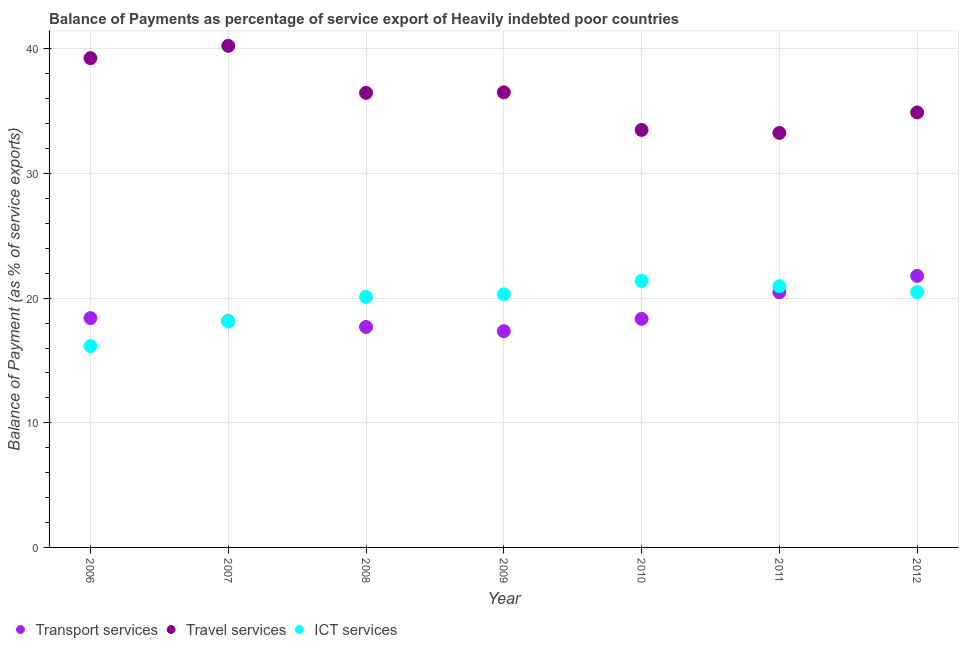Is the number of dotlines equal to the number of legend labels?
Make the answer very short. Yes. What is the balance of payment of ict services in 2012?
Your answer should be compact. 20.48. Across all years, what is the maximum balance of payment of transport services?
Give a very brief answer. 21.79. Across all years, what is the minimum balance of payment of transport services?
Make the answer very short. 17.36. What is the total balance of payment of transport services in the graph?
Your answer should be compact. 132.2. What is the difference between the balance of payment of transport services in 2007 and that in 2010?
Offer a terse response. -0.18. What is the difference between the balance of payment of travel services in 2010 and the balance of payment of transport services in 2012?
Provide a succinct answer. 11.71. What is the average balance of payment of travel services per year?
Provide a succinct answer. 36.31. In the year 2009, what is the difference between the balance of payment of transport services and balance of payment of travel services?
Your answer should be compact. -19.16. In how many years, is the balance of payment of travel services greater than 38 %?
Your answer should be compact. 2. What is the ratio of the balance of payment of transport services in 2008 to that in 2009?
Your response must be concise. 1.02. Is the balance of payment of transport services in 2011 less than that in 2012?
Your answer should be very brief. Yes. Is the difference between the balance of payment of ict services in 2009 and 2012 greater than the difference between the balance of payment of travel services in 2009 and 2012?
Your response must be concise. No. What is the difference between the highest and the second highest balance of payment of ict services?
Make the answer very short. 0.43. What is the difference between the highest and the lowest balance of payment of ict services?
Your response must be concise. 5.23. Is the balance of payment of ict services strictly less than the balance of payment of travel services over the years?
Offer a terse response. Yes. How many years are there in the graph?
Offer a terse response. 7. Does the graph contain any zero values?
Keep it short and to the point. No. Does the graph contain grids?
Keep it short and to the point. Yes. Where does the legend appear in the graph?
Ensure brevity in your answer.  Bottom left. What is the title of the graph?
Your response must be concise. Balance of Payments as percentage of service export of Heavily indebted poor countries. What is the label or title of the X-axis?
Offer a terse response. Year. What is the label or title of the Y-axis?
Provide a short and direct response. Balance of Payment (as % of service exports). What is the Balance of Payment (as % of service exports) in Transport services in 2006?
Make the answer very short. 18.4. What is the Balance of Payment (as % of service exports) of Travel services in 2006?
Provide a short and direct response. 39.26. What is the Balance of Payment (as % of service exports) of ICT services in 2006?
Provide a short and direct response. 16.16. What is the Balance of Payment (as % of service exports) of Transport services in 2007?
Make the answer very short. 18.15. What is the Balance of Payment (as % of service exports) in Travel services in 2007?
Your answer should be compact. 40.25. What is the Balance of Payment (as % of service exports) in ICT services in 2007?
Offer a terse response. 18.15. What is the Balance of Payment (as % of service exports) in Transport services in 2008?
Your answer should be compact. 17.69. What is the Balance of Payment (as % of service exports) of Travel services in 2008?
Provide a short and direct response. 36.48. What is the Balance of Payment (as % of service exports) in ICT services in 2008?
Provide a succinct answer. 20.11. What is the Balance of Payment (as % of service exports) in Transport services in 2009?
Your answer should be compact. 17.36. What is the Balance of Payment (as % of service exports) of Travel services in 2009?
Provide a short and direct response. 36.51. What is the Balance of Payment (as % of service exports) of ICT services in 2009?
Make the answer very short. 20.31. What is the Balance of Payment (as % of service exports) in Transport services in 2010?
Keep it short and to the point. 18.34. What is the Balance of Payment (as % of service exports) in Travel services in 2010?
Ensure brevity in your answer.  33.5. What is the Balance of Payment (as % of service exports) in ICT services in 2010?
Your response must be concise. 21.39. What is the Balance of Payment (as % of service exports) in Transport services in 2011?
Ensure brevity in your answer.  20.48. What is the Balance of Payment (as % of service exports) in Travel services in 2011?
Ensure brevity in your answer.  33.26. What is the Balance of Payment (as % of service exports) of ICT services in 2011?
Give a very brief answer. 20.96. What is the Balance of Payment (as % of service exports) of Transport services in 2012?
Give a very brief answer. 21.79. What is the Balance of Payment (as % of service exports) in Travel services in 2012?
Offer a terse response. 34.91. What is the Balance of Payment (as % of service exports) of ICT services in 2012?
Ensure brevity in your answer.  20.48. Across all years, what is the maximum Balance of Payment (as % of service exports) in Transport services?
Make the answer very short. 21.79. Across all years, what is the maximum Balance of Payment (as % of service exports) of Travel services?
Your answer should be compact. 40.25. Across all years, what is the maximum Balance of Payment (as % of service exports) in ICT services?
Provide a succinct answer. 21.39. Across all years, what is the minimum Balance of Payment (as % of service exports) of Transport services?
Provide a short and direct response. 17.36. Across all years, what is the minimum Balance of Payment (as % of service exports) of Travel services?
Provide a succinct answer. 33.26. Across all years, what is the minimum Balance of Payment (as % of service exports) of ICT services?
Offer a very short reply. 16.16. What is the total Balance of Payment (as % of service exports) in Transport services in the graph?
Provide a short and direct response. 132.2. What is the total Balance of Payment (as % of service exports) of Travel services in the graph?
Make the answer very short. 254.16. What is the total Balance of Payment (as % of service exports) of ICT services in the graph?
Offer a terse response. 137.56. What is the difference between the Balance of Payment (as % of service exports) in Transport services in 2006 and that in 2007?
Keep it short and to the point. 0.25. What is the difference between the Balance of Payment (as % of service exports) in Travel services in 2006 and that in 2007?
Offer a terse response. -0.99. What is the difference between the Balance of Payment (as % of service exports) in ICT services in 2006 and that in 2007?
Give a very brief answer. -1.99. What is the difference between the Balance of Payment (as % of service exports) of Transport services in 2006 and that in 2008?
Give a very brief answer. 0.71. What is the difference between the Balance of Payment (as % of service exports) in Travel services in 2006 and that in 2008?
Offer a very short reply. 2.79. What is the difference between the Balance of Payment (as % of service exports) in ICT services in 2006 and that in 2008?
Provide a succinct answer. -3.95. What is the difference between the Balance of Payment (as % of service exports) of Transport services in 2006 and that in 2009?
Give a very brief answer. 1.05. What is the difference between the Balance of Payment (as % of service exports) of Travel services in 2006 and that in 2009?
Ensure brevity in your answer.  2.75. What is the difference between the Balance of Payment (as % of service exports) in ICT services in 2006 and that in 2009?
Give a very brief answer. -4.15. What is the difference between the Balance of Payment (as % of service exports) of Transport services in 2006 and that in 2010?
Your answer should be very brief. 0.06. What is the difference between the Balance of Payment (as % of service exports) of Travel services in 2006 and that in 2010?
Your answer should be compact. 5.76. What is the difference between the Balance of Payment (as % of service exports) of ICT services in 2006 and that in 2010?
Offer a terse response. -5.23. What is the difference between the Balance of Payment (as % of service exports) of Transport services in 2006 and that in 2011?
Offer a terse response. -2.07. What is the difference between the Balance of Payment (as % of service exports) of Travel services in 2006 and that in 2011?
Offer a very short reply. 6. What is the difference between the Balance of Payment (as % of service exports) in ICT services in 2006 and that in 2011?
Ensure brevity in your answer.  -4.8. What is the difference between the Balance of Payment (as % of service exports) of Transport services in 2006 and that in 2012?
Provide a short and direct response. -3.39. What is the difference between the Balance of Payment (as % of service exports) of Travel services in 2006 and that in 2012?
Provide a short and direct response. 4.36. What is the difference between the Balance of Payment (as % of service exports) of ICT services in 2006 and that in 2012?
Provide a short and direct response. -4.33. What is the difference between the Balance of Payment (as % of service exports) in Transport services in 2007 and that in 2008?
Make the answer very short. 0.47. What is the difference between the Balance of Payment (as % of service exports) in Travel services in 2007 and that in 2008?
Provide a succinct answer. 3.77. What is the difference between the Balance of Payment (as % of service exports) in ICT services in 2007 and that in 2008?
Your answer should be very brief. -1.96. What is the difference between the Balance of Payment (as % of service exports) in Transport services in 2007 and that in 2009?
Make the answer very short. 0.8. What is the difference between the Balance of Payment (as % of service exports) in Travel services in 2007 and that in 2009?
Make the answer very short. 3.73. What is the difference between the Balance of Payment (as % of service exports) of ICT services in 2007 and that in 2009?
Your answer should be very brief. -2.17. What is the difference between the Balance of Payment (as % of service exports) in Transport services in 2007 and that in 2010?
Provide a succinct answer. -0.18. What is the difference between the Balance of Payment (as % of service exports) in Travel services in 2007 and that in 2010?
Provide a short and direct response. 6.75. What is the difference between the Balance of Payment (as % of service exports) of ICT services in 2007 and that in 2010?
Your response must be concise. -3.24. What is the difference between the Balance of Payment (as % of service exports) in Transport services in 2007 and that in 2011?
Your answer should be compact. -2.32. What is the difference between the Balance of Payment (as % of service exports) in Travel services in 2007 and that in 2011?
Ensure brevity in your answer.  6.99. What is the difference between the Balance of Payment (as % of service exports) of ICT services in 2007 and that in 2011?
Provide a short and direct response. -2.82. What is the difference between the Balance of Payment (as % of service exports) of Transport services in 2007 and that in 2012?
Give a very brief answer. -3.64. What is the difference between the Balance of Payment (as % of service exports) of Travel services in 2007 and that in 2012?
Your response must be concise. 5.34. What is the difference between the Balance of Payment (as % of service exports) of ICT services in 2007 and that in 2012?
Offer a terse response. -2.34. What is the difference between the Balance of Payment (as % of service exports) of Transport services in 2008 and that in 2009?
Your answer should be compact. 0.33. What is the difference between the Balance of Payment (as % of service exports) in Travel services in 2008 and that in 2009?
Offer a terse response. -0.04. What is the difference between the Balance of Payment (as % of service exports) of ICT services in 2008 and that in 2009?
Ensure brevity in your answer.  -0.21. What is the difference between the Balance of Payment (as % of service exports) of Transport services in 2008 and that in 2010?
Your response must be concise. -0.65. What is the difference between the Balance of Payment (as % of service exports) in Travel services in 2008 and that in 2010?
Provide a succinct answer. 2.98. What is the difference between the Balance of Payment (as % of service exports) of ICT services in 2008 and that in 2010?
Provide a succinct answer. -1.28. What is the difference between the Balance of Payment (as % of service exports) in Transport services in 2008 and that in 2011?
Offer a terse response. -2.79. What is the difference between the Balance of Payment (as % of service exports) in Travel services in 2008 and that in 2011?
Keep it short and to the point. 3.22. What is the difference between the Balance of Payment (as % of service exports) of ICT services in 2008 and that in 2011?
Your answer should be compact. -0.86. What is the difference between the Balance of Payment (as % of service exports) of Transport services in 2008 and that in 2012?
Provide a short and direct response. -4.1. What is the difference between the Balance of Payment (as % of service exports) of Travel services in 2008 and that in 2012?
Provide a short and direct response. 1.57. What is the difference between the Balance of Payment (as % of service exports) of ICT services in 2008 and that in 2012?
Provide a succinct answer. -0.38. What is the difference between the Balance of Payment (as % of service exports) in Transport services in 2009 and that in 2010?
Offer a terse response. -0.98. What is the difference between the Balance of Payment (as % of service exports) of Travel services in 2009 and that in 2010?
Keep it short and to the point. 3.01. What is the difference between the Balance of Payment (as % of service exports) of ICT services in 2009 and that in 2010?
Make the answer very short. -1.08. What is the difference between the Balance of Payment (as % of service exports) of Transport services in 2009 and that in 2011?
Offer a terse response. -3.12. What is the difference between the Balance of Payment (as % of service exports) in Travel services in 2009 and that in 2011?
Provide a short and direct response. 3.26. What is the difference between the Balance of Payment (as % of service exports) of ICT services in 2009 and that in 2011?
Make the answer very short. -0.65. What is the difference between the Balance of Payment (as % of service exports) of Transport services in 2009 and that in 2012?
Your response must be concise. -4.43. What is the difference between the Balance of Payment (as % of service exports) of Travel services in 2009 and that in 2012?
Your response must be concise. 1.61. What is the difference between the Balance of Payment (as % of service exports) in ICT services in 2009 and that in 2012?
Make the answer very short. -0.17. What is the difference between the Balance of Payment (as % of service exports) of Transport services in 2010 and that in 2011?
Make the answer very short. -2.14. What is the difference between the Balance of Payment (as % of service exports) in Travel services in 2010 and that in 2011?
Your answer should be very brief. 0.24. What is the difference between the Balance of Payment (as % of service exports) of ICT services in 2010 and that in 2011?
Give a very brief answer. 0.43. What is the difference between the Balance of Payment (as % of service exports) of Transport services in 2010 and that in 2012?
Your answer should be very brief. -3.45. What is the difference between the Balance of Payment (as % of service exports) in Travel services in 2010 and that in 2012?
Keep it short and to the point. -1.41. What is the difference between the Balance of Payment (as % of service exports) in ICT services in 2010 and that in 2012?
Ensure brevity in your answer.  0.91. What is the difference between the Balance of Payment (as % of service exports) of Transport services in 2011 and that in 2012?
Keep it short and to the point. -1.31. What is the difference between the Balance of Payment (as % of service exports) in Travel services in 2011 and that in 2012?
Keep it short and to the point. -1.65. What is the difference between the Balance of Payment (as % of service exports) in ICT services in 2011 and that in 2012?
Ensure brevity in your answer.  0.48. What is the difference between the Balance of Payment (as % of service exports) of Transport services in 2006 and the Balance of Payment (as % of service exports) of Travel services in 2007?
Your response must be concise. -21.85. What is the difference between the Balance of Payment (as % of service exports) in Transport services in 2006 and the Balance of Payment (as % of service exports) in ICT services in 2007?
Ensure brevity in your answer.  0.26. What is the difference between the Balance of Payment (as % of service exports) in Travel services in 2006 and the Balance of Payment (as % of service exports) in ICT services in 2007?
Your response must be concise. 21.11. What is the difference between the Balance of Payment (as % of service exports) of Transport services in 2006 and the Balance of Payment (as % of service exports) of Travel services in 2008?
Offer a very short reply. -18.07. What is the difference between the Balance of Payment (as % of service exports) of Transport services in 2006 and the Balance of Payment (as % of service exports) of ICT services in 2008?
Give a very brief answer. -1.7. What is the difference between the Balance of Payment (as % of service exports) of Travel services in 2006 and the Balance of Payment (as % of service exports) of ICT services in 2008?
Provide a succinct answer. 19.16. What is the difference between the Balance of Payment (as % of service exports) of Transport services in 2006 and the Balance of Payment (as % of service exports) of Travel services in 2009?
Provide a succinct answer. -18.11. What is the difference between the Balance of Payment (as % of service exports) of Transport services in 2006 and the Balance of Payment (as % of service exports) of ICT services in 2009?
Ensure brevity in your answer.  -1.91. What is the difference between the Balance of Payment (as % of service exports) in Travel services in 2006 and the Balance of Payment (as % of service exports) in ICT services in 2009?
Your answer should be very brief. 18.95. What is the difference between the Balance of Payment (as % of service exports) of Transport services in 2006 and the Balance of Payment (as % of service exports) of Travel services in 2010?
Your answer should be compact. -15.1. What is the difference between the Balance of Payment (as % of service exports) of Transport services in 2006 and the Balance of Payment (as % of service exports) of ICT services in 2010?
Your answer should be very brief. -2.99. What is the difference between the Balance of Payment (as % of service exports) of Travel services in 2006 and the Balance of Payment (as % of service exports) of ICT services in 2010?
Make the answer very short. 17.87. What is the difference between the Balance of Payment (as % of service exports) of Transport services in 2006 and the Balance of Payment (as % of service exports) of Travel services in 2011?
Keep it short and to the point. -14.86. What is the difference between the Balance of Payment (as % of service exports) of Transport services in 2006 and the Balance of Payment (as % of service exports) of ICT services in 2011?
Make the answer very short. -2.56. What is the difference between the Balance of Payment (as % of service exports) of Travel services in 2006 and the Balance of Payment (as % of service exports) of ICT services in 2011?
Offer a very short reply. 18.3. What is the difference between the Balance of Payment (as % of service exports) of Transport services in 2006 and the Balance of Payment (as % of service exports) of Travel services in 2012?
Offer a very short reply. -16.5. What is the difference between the Balance of Payment (as % of service exports) of Transport services in 2006 and the Balance of Payment (as % of service exports) of ICT services in 2012?
Your answer should be very brief. -2.08. What is the difference between the Balance of Payment (as % of service exports) in Travel services in 2006 and the Balance of Payment (as % of service exports) in ICT services in 2012?
Provide a short and direct response. 18.78. What is the difference between the Balance of Payment (as % of service exports) of Transport services in 2007 and the Balance of Payment (as % of service exports) of Travel services in 2008?
Offer a terse response. -18.32. What is the difference between the Balance of Payment (as % of service exports) in Transport services in 2007 and the Balance of Payment (as % of service exports) in ICT services in 2008?
Provide a succinct answer. -1.95. What is the difference between the Balance of Payment (as % of service exports) of Travel services in 2007 and the Balance of Payment (as % of service exports) of ICT services in 2008?
Provide a succinct answer. 20.14. What is the difference between the Balance of Payment (as % of service exports) of Transport services in 2007 and the Balance of Payment (as % of service exports) of Travel services in 2009?
Offer a very short reply. -18.36. What is the difference between the Balance of Payment (as % of service exports) of Transport services in 2007 and the Balance of Payment (as % of service exports) of ICT services in 2009?
Offer a terse response. -2.16. What is the difference between the Balance of Payment (as % of service exports) in Travel services in 2007 and the Balance of Payment (as % of service exports) in ICT services in 2009?
Provide a short and direct response. 19.94. What is the difference between the Balance of Payment (as % of service exports) of Transport services in 2007 and the Balance of Payment (as % of service exports) of Travel services in 2010?
Offer a very short reply. -15.35. What is the difference between the Balance of Payment (as % of service exports) in Transport services in 2007 and the Balance of Payment (as % of service exports) in ICT services in 2010?
Ensure brevity in your answer.  -3.23. What is the difference between the Balance of Payment (as % of service exports) in Travel services in 2007 and the Balance of Payment (as % of service exports) in ICT services in 2010?
Offer a terse response. 18.86. What is the difference between the Balance of Payment (as % of service exports) in Transport services in 2007 and the Balance of Payment (as % of service exports) in Travel services in 2011?
Your answer should be compact. -15.11. What is the difference between the Balance of Payment (as % of service exports) of Transport services in 2007 and the Balance of Payment (as % of service exports) of ICT services in 2011?
Your answer should be very brief. -2.81. What is the difference between the Balance of Payment (as % of service exports) in Travel services in 2007 and the Balance of Payment (as % of service exports) in ICT services in 2011?
Your answer should be compact. 19.29. What is the difference between the Balance of Payment (as % of service exports) of Transport services in 2007 and the Balance of Payment (as % of service exports) of Travel services in 2012?
Provide a short and direct response. -16.75. What is the difference between the Balance of Payment (as % of service exports) of Transport services in 2007 and the Balance of Payment (as % of service exports) of ICT services in 2012?
Keep it short and to the point. -2.33. What is the difference between the Balance of Payment (as % of service exports) in Travel services in 2007 and the Balance of Payment (as % of service exports) in ICT services in 2012?
Provide a short and direct response. 19.77. What is the difference between the Balance of Payment (as % of service exports) in Transport services in 2008 and the Balance of Payment (as % of service exports) in Travel services in 2009?
Offer a terse response. -18.83. What is the difference between the Balance of Payment (as % of service exports) of Transport services in 2008 and the Balance of Payment (as % of service exports) of ICT services in 2009?
Make the answer very short. -2.62. What is the difference between the Balance of Payment (as % of service exports) in Travel services in 2008 and the Balance of Payment (as % of service exports) in ICT services in 2009?
Provide a short and direct response. 16.16. What is the difference between the Balance of Payment (as % of service exports) of Transport services in 2008 and the Balance of Payment (as % of service exports) of Travel services in 2010?
Offer a terse response. -15.81. What is the difference between the Balance of Payment (as % of service exports) in Transport services in 2008 and the Balance of Payment (as % of service exports) in ICT services in 2010?
Your answer should be very brief. -3.7. What is the difference between the Balance of Payment (as % of service exports) in Travel services in 2008 and the Balance of Payment (as % of service exports) in ICT services in 2010?
Offer a very short reply. 15.09. What is the difference between the Balance of Payment (as % of service exports) of Transport services in 2008 and the Balance of Payment (as % of service exports) of Travel services in 2011?
Give a very brief answer. -15.57. What is the difference between the Balance of Payment (as % of service exports) in Transport services in 2008 and the Balance of Payment (as % of service exports) in ICT services in 2011?
Provide a short and direct response. -3.27. What is the difference between the Balance of Payment (as % of service exports) of Travel services in 2008 and the Balance of Payment (as % of service exports) of ICT services in 2011?
Ensure brevity in your answer.  15.51. What is the difference between the Balance of Payment (as % of service exports) of Transport services in 2008 and the Balance of Payment (as % of service exports) of Travel services in 2012?
Provide a short and direct response. -17.22. What is the difference between the Balance of Payment (as % of service exports) in Transport services in 2008 and the Balance of Payment (as % of service exports) in ICT services in 2012?
Provide a short and direct response. -2.79. What is the difference between the Balance of Payment (as % of service exports) in Travel services in 2008 and the Balance of Payment (as % of service exports) in ICT services in 2012?
Ensure brevity in your answer.  15.99. What is the difference between the Balance of Payment (as % of service exports) in Transport services in 2009 and the Balance of Payment (as % of service exports) in Travel services in 2010?
Keep it short and to the point. -16.14. What is the difference between the Balance of Payment (as % of service exports) of Transport services in 2009 and the Balance of Payment (as % of service exports) of ICT services in 2010?
Keep it short and to the point. -4.03. What is the difference between the Balance of Payment (as % of service exports) of Travel services in 2009 and the Balance of Payment (as % of service exports) of ICT services in 2010?
Give a very brief answer. 15.13. What is the difference between the Balance of Payment (as % of service exports) of Transport services in 2009 and the Balance of Payment (as % of service exports) of Travel services in 2011?
Your answer should be compact. -15.9. What is the difference between the Balance of Payment (as % of service exports) of Transport services in 2009 and the Balance of Payment (as % of service exports) of ICT services in 2011?
Ensure brevity in your answer.  -3.61. What is the difference between the Balance of Payment (as % of service exports) of Travel services in 2009 and the Balance of Payment (as % of service exports) of ICT services in 2011?
Your answer should be very brief. 15.55. What is the difference between the Balance of Payment (as % of service exports) of Transport services in 2009 and the Balance of Payment (as % of service exports) of Travel services in 2012?
Offer a terse response. -17.55. What is the difference between the Balance of Payment (as % of service exports) in Transport services in 2009 and the Balance of Payment (as % of service exports) in ICT services in 2012?
Ensure brevity in your answer.  -3.13. What is the difference between the Balance of Payment (as % of service exports) in Travel services in 2009 and the Balance of Payment (as % of service exports) in ICT services in 2012?
Offer a terse response. 16.03. What is the difference between the Balance of Payment (as % of service exports) in Transport services in 2010 and the Balance of Payment (as % of service exports) in Travel services in 2011?
Keep it short and to the point. -14.92. What is the difference between the Balance of Payment (as % of service exports) in Transport services in 2010 and the Balance of Payment (as % of service exports) in ICT services in 2011?
Keep it short and to the point. -2.62. What is the difference between the Balance of Payment (as % of service exports) of Travel services in 2010 and the Balance of Payment (as % of service exports) of ICT services in 2011?
Offer a terse response. 12.54. What is the difference between the Balance of Payment (as % of service exports) of Transport services in 2010 and the Balance of Payment (as % of service exports) of Travel services in 2012?
Offer a terse response. -16.57. What is the difference between the Balance of Payment (as % of service exports) of Transport services in 2010 and the Balance of Payment (as % of service exports) of ICT services in 2012?
Your answer should be compact. -2.14. What is the difference between the Balance of Payment (as % of service exports) in Travel services in 2010 and the Balance of Payment (as % of service exports) in ICT services in 2012?
Your answer should be very brief. 13.02. What is the difference between the Balance of Payment (as % of service exports) of Transport services in 2011 and the Balance of Payment (as % of service exports) of Travel services in 2012?
Provide a succinct answer. -14.43. What is the difference between the Balance of Payment (as % of service exports) in Transport services in 2011 and the Balance of Payment (as % of service exports) in ICT services in 2012?
Offer a terse response. -0.01. What is the difference between the Balance of Payment (as % of service exports) of Travel services in 2011 and the Balance of Payment (as % of service exports) of ICT services in 2012?
Your response must be concise. 12.78. What is the average Balance of Payment (as % of service exports) in Transport services per year?
Your answer should be compact. 18.89. What is the average Balance of Payment (as % of service exports) of Travel services per year?
Make the answer very short. 36.31. What is the average Balance of Payment (as % of service exports) in ICT services per year?
Your answer should be very brief. 19.65. In the year 2006, what is the difference between the Balance of Payment (as % of service exports) in Transport services and Balance of Payment (as % of service exports) in Travel services?
Keep it short and to the point. -20.86. In the year 2006, what is the difference between the Balance of Payment (as % of service exports) in Transport services and Balance of Payment (as % of service exports) in ICT services?
Provide a succinct answer. 2.24. In the year 2006, what is the difference between the Balance of Payment (as % of service exports) of Travel services and Balance of Payment (as % of service exports) of ICT services?
Ensure brevity in your answer.  23.1. In the year 2007, what is the difference between the Balance of Payment (as % of service exports) of Transport services and Balance of Payment (as % of service exports) of Travel services?
Offer a very short reply. -22.1. In the year 2007, what is the difference between the Balance of Payment (as % of service exports) of Transport services and Balance of Payment (as % of service exports) of ICT services?
Your answer should be compact. 0.01. In the year 2007, what is the difference between the Balance of Payment (as % of service exports) of Travel services and Balance of Payment (as % of service exports) of ICT services?
Your answer should be very brief. 22.1. In the year 2008, what is the difference between the Balance of Payment (as % of service exports) of Transport services and Balance of Payment (as % of service exports) of Travel services?
Ensure brevity in your answer.  -18.79. In the year 2008, what is the difference between the Balance of Payment (as % of service exports) in Transport services and Balance of Payment (as % of service exports) in ICT services?
Provide a succinct answer. -2.42. In the year 2008, what is the difference between the Balance of Payment (as % of service exports) of Travel services and Balance of Payment (as % of service exports) of ICT services?
Give a very brief answer. 16.37. In the year 2009, what is the difference between the Balance of Payment (as % of service exports) in Transport services and Balance of Payment (as % of service exports) in Travel services?
Offer a terse response. -19.16. In the year 2009, what is the difference between the Balance of Payment (as % of service exports) of Transport services and Balance of Payment (as % of service exports) of ICT services?
Provide a short and direct response. -2.96. In the year 2009, what is the difference between the Balance of Payment (as % of service exports) of Travel services and Balance of Payment (as % of service exports) of ICT services?
Provide a short and direct response. 16.2. In the year 2010, what is the difference between the Balance of Payment (as % of service exports) in Transport services and Balance of Payment (as % of service exports) in Travel services?
Offer a terse response. -15.16. In the year 2010, what is the difference between the Balance of Payment (as % of service exports) in Transport services and Balance of Payment (as % of service exports) in ICT services?
Your answer should be very brief. -3.05. In the year 2010, what is the difference between the Balance of Payment (as % of service exports) in Travel services and Balance of Payment (as % of service exports) in ICT services?
Provide a succinct answer. 12.11. In the year 2011, what is the difference between the Balance of Payment (as % of service exports) in Transport services and Balance of Payment (as % of service exports) in Travel services?
Ensure brevity in your answer.  -12.78. In the year 2011, what is the difference between the Balance of Payment (as % of service exports) of Transport services and Balance of Payment (as % of service exports) of ICT services?
Ensure brevity in your answer.  -0.49. In the year 2011, what is the difference between the Balance of Payment (as % of service exports) in Travel services and Balance of Payment (as % of service exports) in ICT services?
Offer a very short reply. 12.3. In the year 2012, what is the difference between the Balance of Payment (as % of service exports) in Transport services and Balance of Payment (as % of service exports) in Travel services?
Your response must be concise. -13.11. In the year 2012, what is the difference between the Balance of Payment (as % of service exports) in Transport services and Balance of Payment (as % of service exports) in ICT services?
Make the answer very short. 1.31. In the year 2012, what is the difference between the Balance of Payment (as % of service exports) in Travel services and Balance of Payment (as % of service exports) in ICT services?
Your answer should be compact. 14.42. What is the ratio of the Balance of Payment (as % of service exports) of Transport services in 2006 to that in 2007?
Offer a very short reply. 1.01. What is the ratio of the Balance of Payment (as % of service exports) of Travel services in 2006 to that in 2007?
Make the answer very short. 0.98. What is the ratio of the Balance of Payment (as % of service exports) in ICT services in 2006 to that in 2007?
Your answer should be very brief. 0.89. What is the ratio of the Balance of Payment (as % of service exports) in Transport services in 2006 to that in 2008?
Your answer should be very brief. 1.04. What is the ratio of the Balance of Payment (as % of service exports) in Travel services in 2006 to that in 2008?
Offer a very short reply. 1.08. What is the ratio of the Balance of Payment (as % of service exports) in ICT services in 2006 to that in 2008?
Offer a terse response. 0.8. What is the ratio of the Balance of Payment (as % of service exports) in Transport services in 2006 to that in 2009?
Offer a very short reply. 1.06. What is the ratio of the Balance of Payment (as % of service exports) in Travel services in 2006 to that in 2009?
Provide a succinct answer. 1.08. What is the ratio of the Balance of Payment (as % of service exports) of ICT services in 2006 to that in 2009?
Provide a short and direct response. 0.8. What is the ratio of the Balance of Payment (as % of service exports) in Travel services in 2006 to that in 2010?
Ensure brevity in your answer.  1.17. What is the ratio of the Balance of Payment (as % of service exports) in ICT services in 2006 to that in 2010?
Give a very brief answer. 0.76. What is the ratio of the Balance of Payment (as % of service exports) of Transport services in 2006 to that in 2011?
Offer a terse response. 0.9. What is the ratio of the Balance of Payment (as % of service exports) of Travel services in 2006 to that in 2011?
Your answer should be compact. 1.18. What is the ratio of the Balance of Payment (as % of service exports) in ICT services in 2006 to that in 2011?
Ensure brevity in your answer.  0.77. What is the ratio of the Balance of Payment (as % of service exports) in Transport services in 2006 to that in 2012?
Offer a terse response. 0.84. What is the ratio of the Balance of Payment (as % of service exports) of Travel services in 2006 to that in 2012?
Provide a short and direct response. 1.12. What is the ratio of the Balance of Payment (as % of service exports) of ICT services in 2006 to that in 2012?
Keep it short and to the point. 0.79. What is the ratio of the Balance of Payment (as % of service exports) of Transport services in 2007 to that in 2008?
Keep it short and to the point. 1.03. What is the ratio of the Balance of Payment (as % of service exports) in Travel services in 2007 to that in 2008?
Your answer should be compact. 1.1. What is the ratio of the Balance of Payment (as % of service exports) of ICT services in 2007 to that in 2008?
Offer a terse response. 0.9. What is the ratio of the Balance of Payment (as % of service exports) of Transport services in 2007 to that in 2009?
Your response must be concise. 1.05. What is the ratio of the Balance of Payment (as % of service exports) of Travel services in 2007 to that in 2009?
Ensure brevity in your answer.  1.1. What is the ratio of the Balance of Payment (as % of service exports) in ICT services in 2007 to that in 2009?
Your answer should be compact. 0.89. What is the ratio of the Balance of Payment (as % of service exports) of Travel services in 2007 to that in 2010?
Your response must be concise. 1.2. What is the ratio of the Balance of Payment (as % of service exports) in ICT services in 2007 to that in 2010?
Provide a short and direct response. 0.85. What is the ratio of the Balance of Payment (as % of service exports) in Transport services in 2007 to that in 2011?
Offer a terse response. 0.89. What is the ratio of the Balance of Payment (as % of service exports) in Travel services in 2007 to that in 2011?
Make the answer very short. 1.21. What is the ratio of the Balance of Payment (as % of service exports) of ICT services in 2007 to that in 2011?
Make the answer very short. 0.87. What is the ratio of the Balance of Payment (as % of service exports) of Transport services in 2007 to that in 2012?
Provide a succinct answer. 0.83. What is the ratio of the Balance of Payment (as % of service exports) of Travel services in 2007 to that in 2012?
Ensure brevity in your answer.  1.15. What is the ratio of the Balance of Payment (as % of service exports) of ICT services in 2007 to that in 2012?
Give a very brief answer. 0.89. What is the ratio of the Balance of Payment (as % of service exports) of Transport services in 2008 to that in 2009?
Offer a very short reply. 1.02. What is the ratio of the Balance of Payment (as % of service exports) in Travel services in 2008 to that in 2009?
Make the answer very short. 1. What is the ratio of the Balance of Payment (as % of service exports) in Transport services in 2008 to that in 2010?
Keep it short and to the point. 0.96. What is the ratio of the Balance of Payment (as % of service exports) of Travel services in 2008 to that in 2010?
Ensure brevity in your answer.  1.09. What is the ratio of the Balance of Payment (as % of service exports) in ICT services in 2008 to that in 2010?
Your answer should be very brief. 0.94. What is the ratio of the Balance of Payment (as % of service exports) in Transport services in 2008 to that in 2011?
Offer a terse response. 0.86. What is the ratio of the Balance of Payment (as % of service exports) in Travel services in 2008 to that in 2011?
Your answer should be compact. 1.1. What is the ratio of the Balance of Payment (as % of service exports) of ICT services in 2008 to that in 2011?
Provide a short and direct response. 0.96. What is the ratio of the Balance of Payment (as % of service exports) in Transport services in 2008 to that in 2012?
Give a very brief answer. 0.81. What is the ratio of the Balance of Payment (as % of service exports) of Travel services in 2008 to that in 2012?
Your response must be concise. 1.04. What is the ratio of the Balance of Payment (as % of service exports) of ICT services in 2008 to that in 2012?
Your response must be concise. 0.98. What is the ratio of the Balance of Payment (as % of service exports) in Transport services in 2009 to that in 2010?
Your response must be concise. 0.95. What is the ratio of the Balance of Payment (as % of service exports) of Travel services in 2009 to that in 2010?
Ensure brevity in your answer.  1.09. What is the ratio of the Balance of Payment (as % of service exports) of ICT services in 2009 to that in 2010?
Offer a terse response. 0.95. What is the ratio of the Balance of Payment (as % of service exports) of Transport services in 2009 to that in 2011?
Your response must be concise. 0.85. What is the ratio of the Balance of Payment (as % of service exports) of Travel services in 2009 to that in 2011?
Give a very brief answer. 1.1. What is the ratio of the Balance of Payment (as % of service exports) of ICT services in 2009 to that in 2011?
Offer a terse response. 0.97. What is the ratio of the Balance of Payment (as % of service exports) of Transport services in 2009 to that in 2012?
Keep it short and to the point. 0.8. What is the ratio of the Balance of Payment (as % of service exports) of Travel services in 2009 to that in 2012?
Give a very brief answer. 1.05. What is the ratio of the Balance of Payment (as % of service exports) in ICT services in 2009 to that in 2012?
Offer a terse response. 0.99. What is the ratio of the Balance of Payment (as % of service exports) in Transport services in 2010 to that in 2011?
Offer a terse response. 0.9. What is the ratio of the Balance of Payment (as % of service exports) of Travel services in 2010 to that in 2011?
Your response must be concise. 1.01. What is the ratio of the Balance of Payment (as % of service exports) in ICT services in 2010 to that in 2011?
Provide a short and direct response. 1.02. What is the ratio of the Balance of Payment (as % of service exports) in Transport services in 2010 to that in 2012?
Offer a terse response. 0.84. What is the ratio of the Balance of Payment (as % of service exports) in Travel services in 2010 to that in 2012?
Keep it short and to the point. 0.96. What is the ratio of the Balance of Payment (as % of service exports) in ICT services in 2010 to that in 2012?
Your answer should be very brief. 1.04. What is the ratio of the Balance of Payment (as % of service exports) in Transport services in 2011 to that in 2012?
Offer a very short reply. 0.94. What is the ratio of the Balance of Payment (as % of service exports) in Travel services in 2011 to that in 2012?
Provide a succinct answer. 0.95. What is the ratio of the Balance of Payment (as % of service exports) of ICT services in 2011 to that in 2012?
Offer a very short reply. 1.02. What is the difference between the highest and the second highest Balance of Payment (as % of service exports) of Transport services?
Ensure brevity in your answer.  1.31. What is the difference between the highest and the second highest Balance of Payment (as % of service exports) in ICT services?
Keep it short and to the point. 0.43. What is the difference between the highest and the lowest Balance of Payment (as % of service exports) in Transport services?
Provide a short and direct response. 4.43. What is the difference between the highest and the lowest Balance of Payment (as % of service exports) of Travel services?
Your answer should be very brief. 6.99. What is the difference between the highest and the lowest Balance of Payment (as % of service exports) of ICT services?
Make the answer very short. 5.23. 